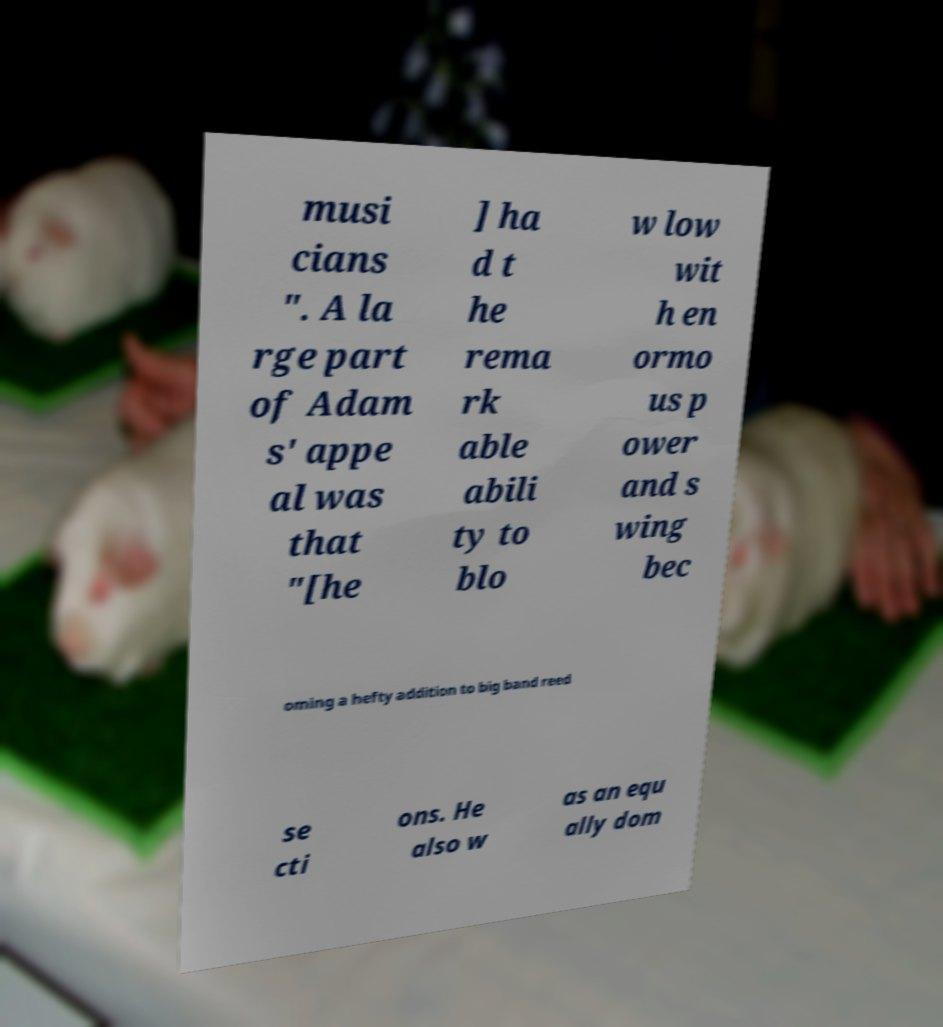There's text embedded in this image that I need extracted. Can you transcribe it verbatim? musi cians ". A la rge part of Adam s' appe al was that "[he ] ha d t he rema rk able abili ty to blo w low wit h en ormo us p ower and s wing bec oming a hefty addition to big band reed se cti ons. He also w as an equ ally dom 